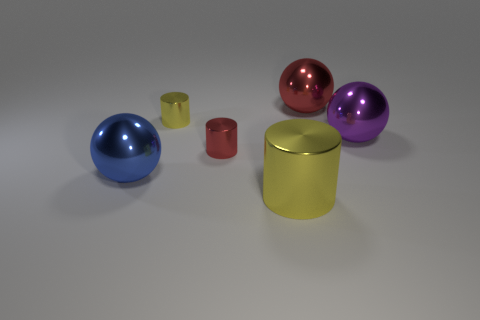What number of small things are either red spheres or purple metal spheres?
Ensure brevity in your answer.  0. How many other objects are the same color as the large metal cylinder?
Provide a succinct answer. 1. How many big shiny things are behind the sphere on the left side of the cylinder left of the tiny red shiny cylinder?
Ensure brevity in your answer.  2. Is the size of the yellow shiny thing behind the purple metallic ball the same as the large red sphere?
Offer a very short reply. No. Is the number of big purple spheres behind the large purple ball less than the number of purple shiny objects in front of the tiny yellow shiny object?
Keep it short and to the point. Yes. Is the number of purple metal objects that are left of the large yellow cylinder less than the number of large metallic objects?
Provide a succinct answer. Yes. What material is the tiny cylinder that is the same color as the large cylinder?
Offer a terse response. Metal. Do the small yellow object and the red cylinder have the same material?
Provide a succinct answer. Yes. How many big cylinders are made of the same material as the tiny red cylinder?
Your response must be concise. 1. There is a large cylinder that is made of the same material as the small yellow cylinder; what is its color?
Your answer should be very brief. Yellow. 